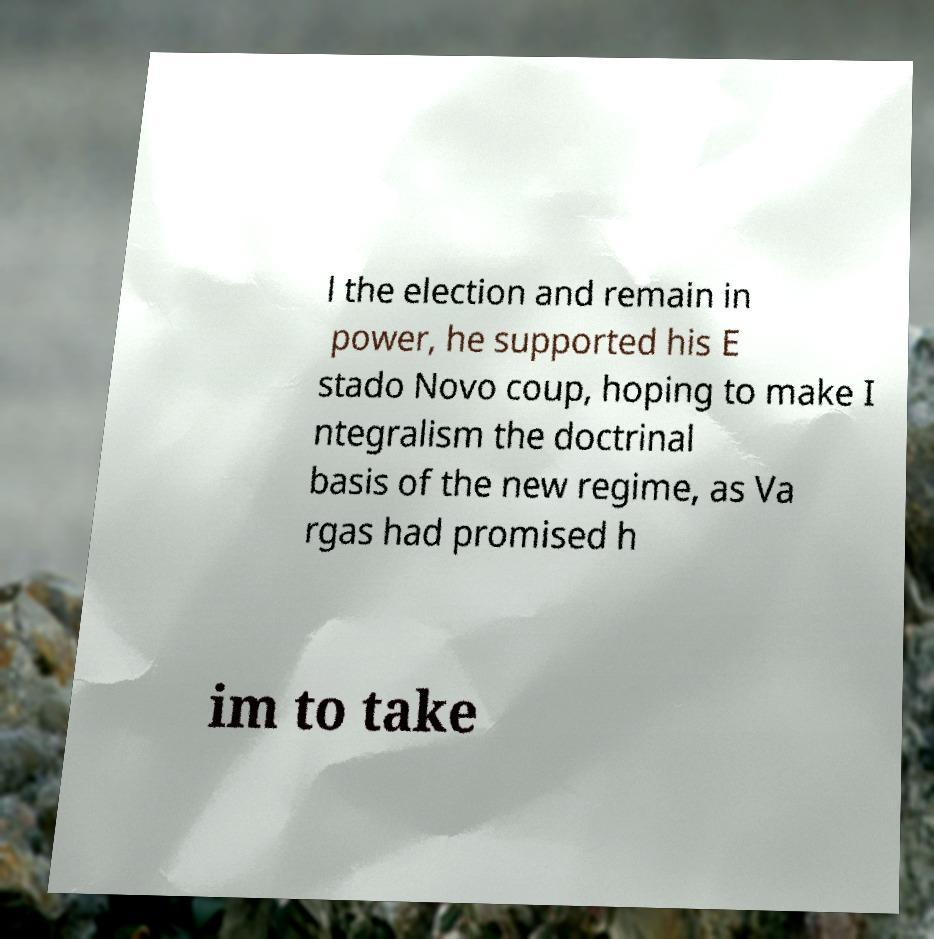Please identify and transcribe the text found in this image. l the election and remain in power, he supported his E stado Novo coup, hoping to make I ntegralism the doctrinal basis of the new regime, as Va rgas had promised h im to take 